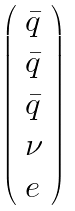<formula> <loc_0><loc_0><loc_500><loc_500>\left ( \begin{array} { l } { { \bar { q } } } \\ { { \bar { q } } } \\ { { \bar { q } } } \\ { \nu } \\ { e } \end{array} \right )</formula> 